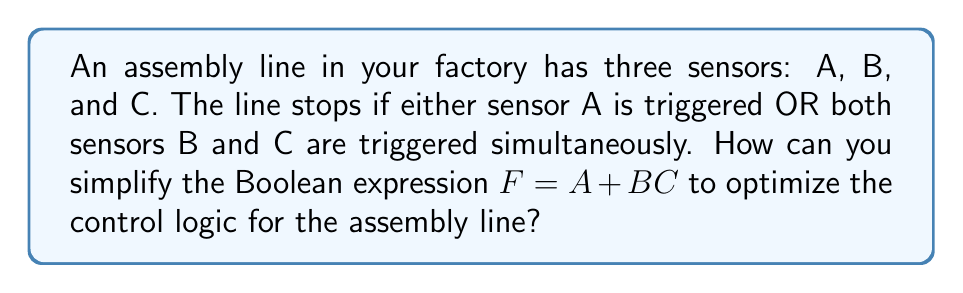Provide a solution to this math problem. Let's simplify the Boolean expression $F = A + BC$ step-by-step:

1. First, we can apply the distributive law to expand the expression:
   $F = A + BC$
   $F = (A + B)(A + C)$

2. Expanding the right side:
   $F = AA + AC + BA + BC$

3. Simplify using the idempotent law (AA = A):
   $F = A + AC + BA + BC$

4. Group terms with A:
   $F = A(1 + C) + BA + BC$

5. Simplify using the identity law (1 + C = 1):
   $F = A + BA + BC$

6. Factor out B from the last two terms:
   $F = A + B(A + C)$

This simplified form $A + B(A + C)$ is equivalent to the original expression but requires fewer logical operations, potentially reducing the complexity of the control system and improving the efficiency of the assembly line.
Answer: $F = A + B(A + C)$ 